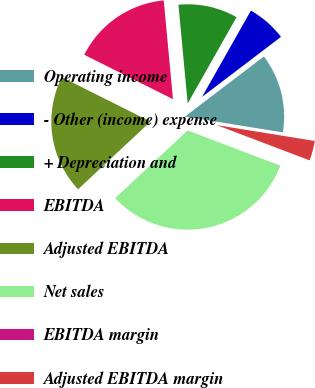Convert chart. <chart><loc_0><loc_0><loc_500><loc_500><pie_chart><fcel>Operating income<fcel>- Other (income) expense<fcel>+ Depreciation and<fcel>EBITDA<fcel>Adjusted EBITDA<fcel>Net sales<fcel>EBITDA margin<fcel>Adjusted EBITDA margin<nl><fcel>12.9%<fcel>6.45%<fcel>9.68%<fcel>16.13%<fcel>19.35%<fcel>32.26%<fcel>0.0%<fcel>3.23%<nl></chart> 